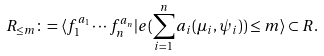Convert formula to latex. <formula><loc_0><loc_0><loc_500><loc_500>R _ { \leq m } \colon = \langle f _ { 1 } ^ { a _ { 1 } } \cdots f _ { n } ^ { a _ { n } } | e ( \sum _ { i = 1 } ^ { n } a _ { i } ( \mu _ { i } , \psi _ { i } ) ) \leq m \rangle \subset R .</formula> 